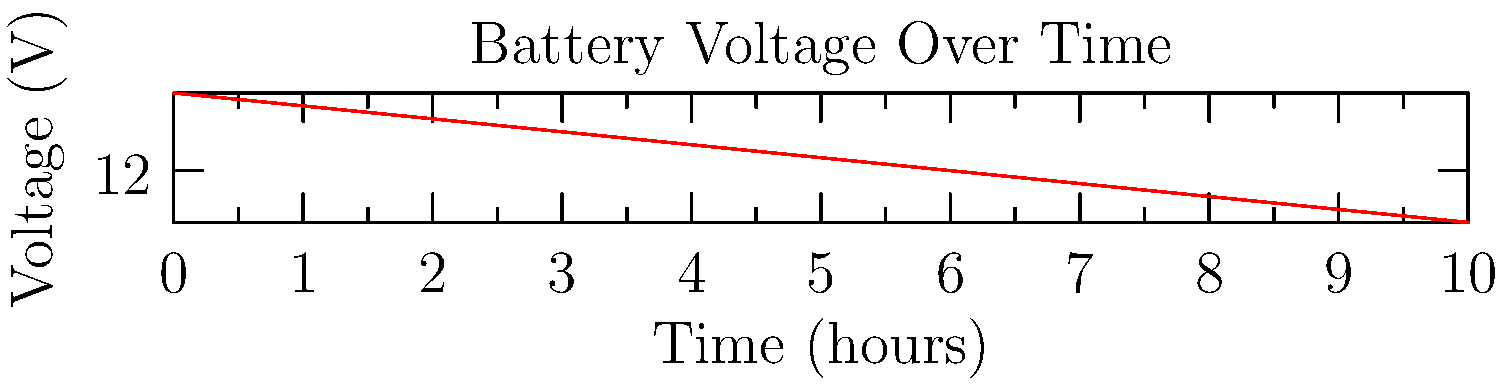Based on the voltage vs. time chart for a car battery, what type of fault is most likely occurring? To identify the fault in the car battery based on the voltage vs. time chart, we need to analyze the trend:

1. The graph shows a steady decrease in voltage over time.
2. The initial voltage is 12.6V, which is typical for a fully charged car battery.
3. Over 10 hours, the voltage drops to 11.6V, which is a significant decrease.
4. The rate of voltage drop is approximately 0.1V per hour.

This behavior indicates:

a) The battery is discharging without being recharged.
b) The rate of discharge is relatively slow but consistent.
c) There's no sudden drop or fluctuation in voltage.

Given these observations, the most likely fault is:

- A parasitic drain on the battery. This occurs when an electrical component in the car continues to draw power even when the vehicle is turned off.

Common causes of parasitic drain include:
- Faulty alternator diode
- Trunk, glove box, or dome lights staying on
- Malfunctioning audio system
- Short circuit in the electrical system

As a service manager overseeing roadside assistance technicians, identifying this issue quickly can help in providing efficient service and preventing unnecessary battery replacements.
Answer: Parasitic drain 